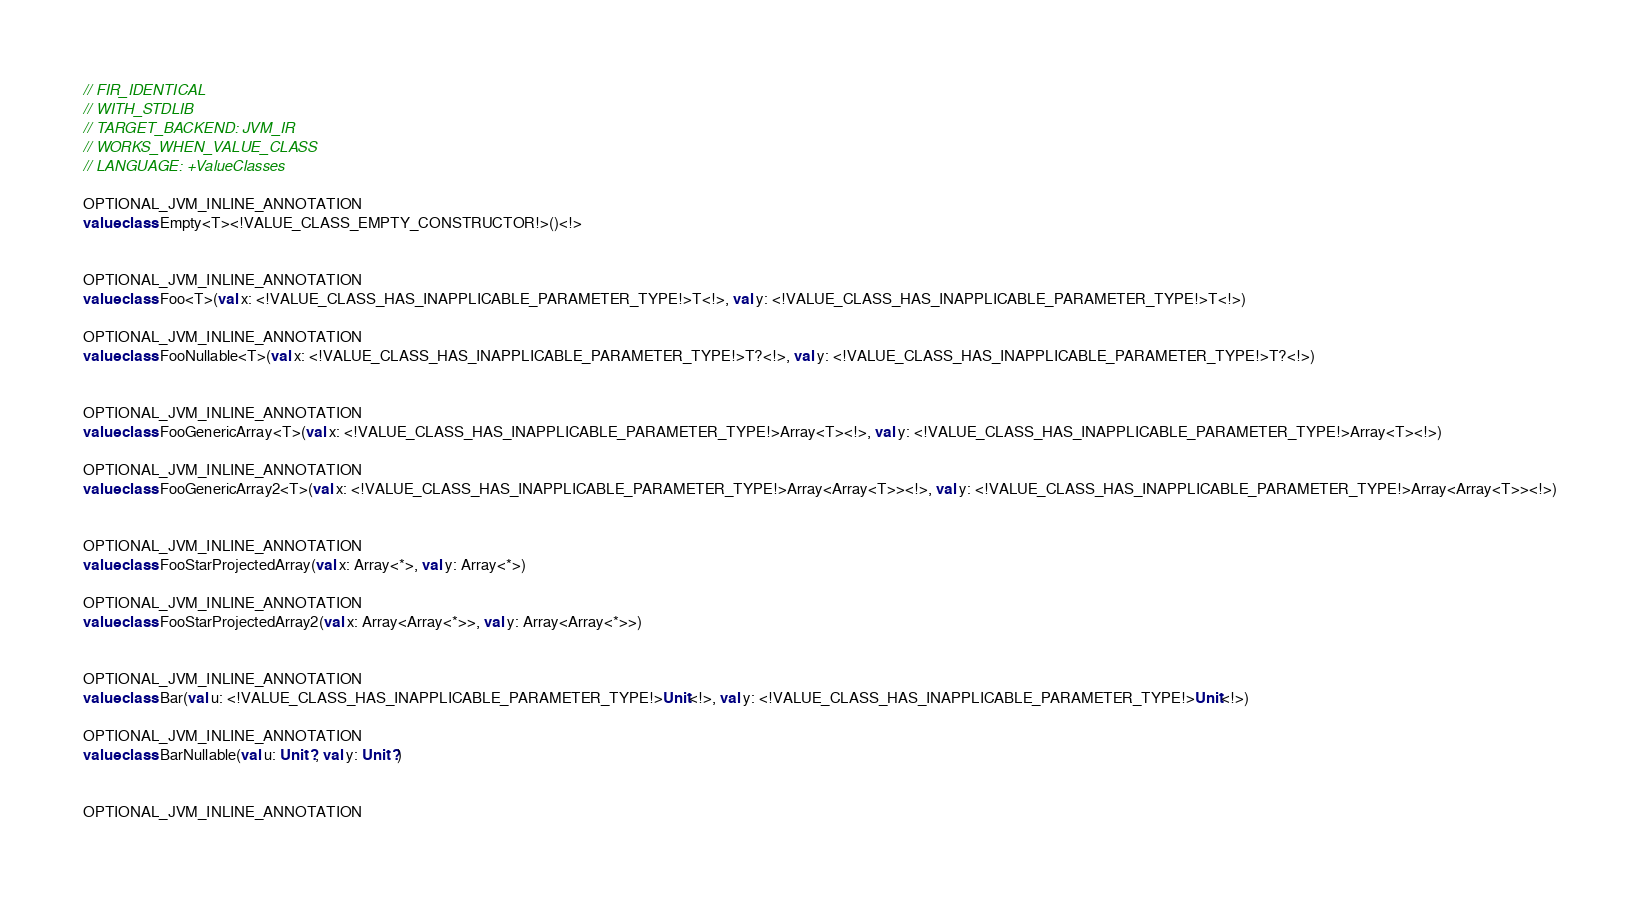Convert code to text. <code><loc_0><loc_0><loc_500><loc_500><_Kotlin_>// FIR_IDENTICAL
// WITH_STDLIB
// TARGET_BACKEND: JVM_IR
// WORKS_WHEN_VALUE_CLASS
// LANGUAGE: +ValueClasses

OPTIONAL_JVM_INLINE_ANNOTATION
value class Empty<T><!VALUE_CLASS_EMPTY_CONSTRUCTOR!>()<!>


OPTIONAL_JVM_INLINE_ANNOTATION
value class Foo<T>(val x: <!VALUE_CLASS_HAS_INAPPLICABLE_PARAMETER_TYPE!>T<!>, val y: <!VALUE_CLASS_HAS_INAPPLICABLE_PARAMETER_TYPE!>T<!>)

OPTIONAL_JVM_INLINE_ANNOTATION
value class FooNullable<T>(val x: <!VALUE_CLASS_HAS_INAPPLICABLE_PARAMETER_TYPE!>T?<!>, val y: <!VALUE_CLASS_HAS_INAPPLICABLE_PARAMETER_TYPE!>T?<!>)


OPTIONAL_JVM_INLINE_ANNOTATION
value class FooGenericArray<T>(val x: <!VALUE_CLASS_HAS_INAPPLICABLE_PARAMETER_TYPE!>Array<T><!>, val y: <!VALUE_CLASS_HAS_INAPPLICABLE_PARAMETER_TYPE!>Array<T><!>)

OPTIONAL_JVM_INLINE_ANNOTATION
value class FooGenericArray2<T>(val x: <!VALUE_CLASS_HAS_INAPPLICABLE_PARAMETER_TYPE!>Array<Array<T>><!>, val y: <!VALUE_CLASS_HAS_INAPPLICABLE_PARAMETER_TYPE!>Array<Array<T>><!>)


OPTIONAL_JVM_INLINE_ANNOTATION
value class FooStarProjectedArray(val x: Array<*>, val y: Array<*>)

OPTIONAL_JVM_INLINE_ANNOTATION
value class FooStarProjectedArray2(val x: Array<Array<*>>, val y: Array<Array<*>>)


OPTIONAL_JVM_INLINE_ANNOTATION
value class Bar(val u: <!VALUE_CLASS_HAS_INAPPLICABLE_PARAMETER_TYPE!>Unit<!>, val y: <!VALUE_CLASS_HAS_INAPPLICABLE_PARAMETER_TYPE!>Unit<!>)

OPTIONAL_JVM_INLINE_ANNOTATION
value class BarNullable(val u: Unit?, val y: Unit?)


OPTIONAL_JVM_INLINE_ANNOTATION</code> 